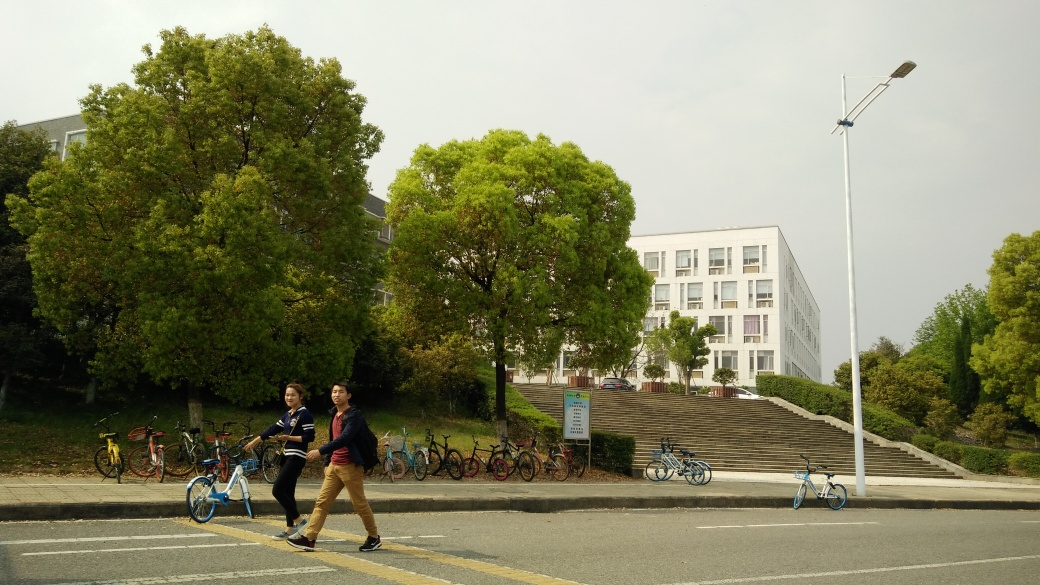What is the atmosphere conveyed by the people and setting in the image? The image portrays a relaxed, almost tranquil atmosphere with individuals casually walking, likely pedestrians going about their daily activities. The presence of green spaces and orderly parked bicycles adds a sense of organization and calm to the setting. The overall impression is one of peaceful coexistence with the environment and an active lifestyle. Could you elaborate on the type of location where this image might have been taken? Considering the combination of features such as the institutional-style building, the orderly parked bicycles, and the casual demeanor of the pedestrians, this image likely depicts a scene from a college or university campus. It might even be located in a suburban setting given the open space and relative lack of crowdedness. 